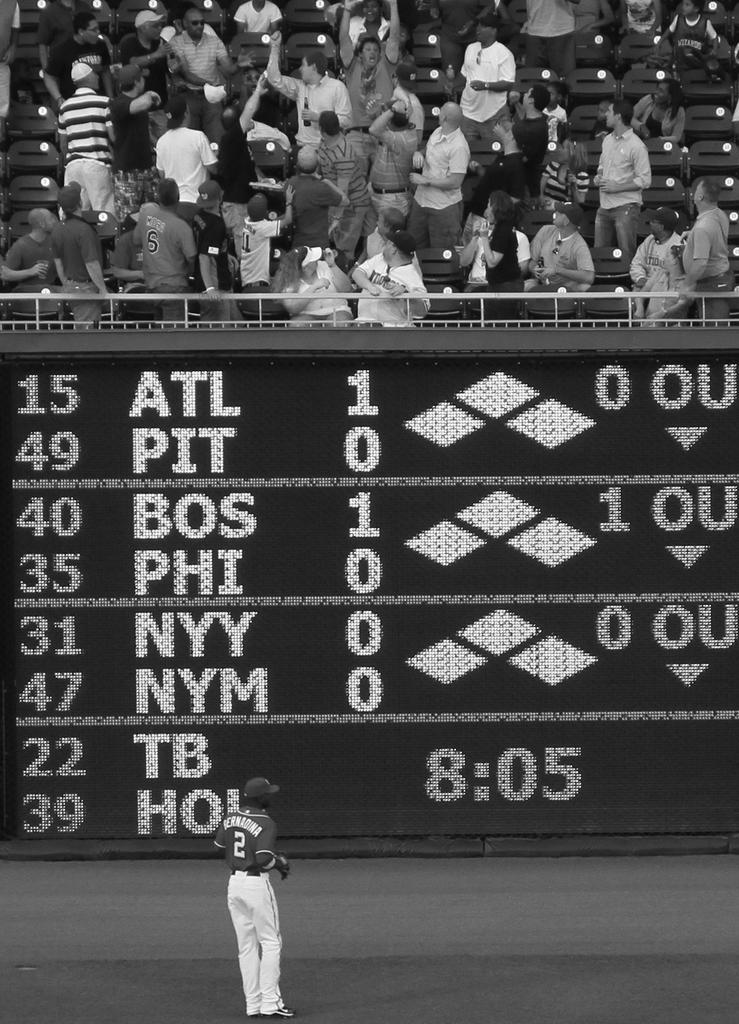Provide a one-sentence caption for the provided image. people in stands trying to find ball while player #2 bernadina stands in the outfield. 